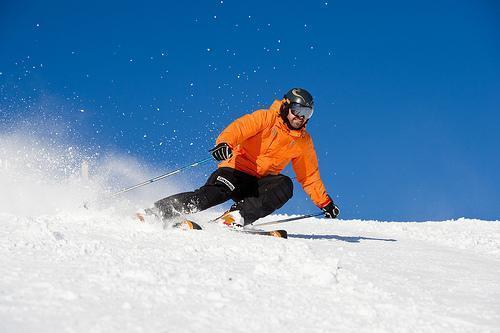How many skiers are there?
Give a very brief answer. 1. 